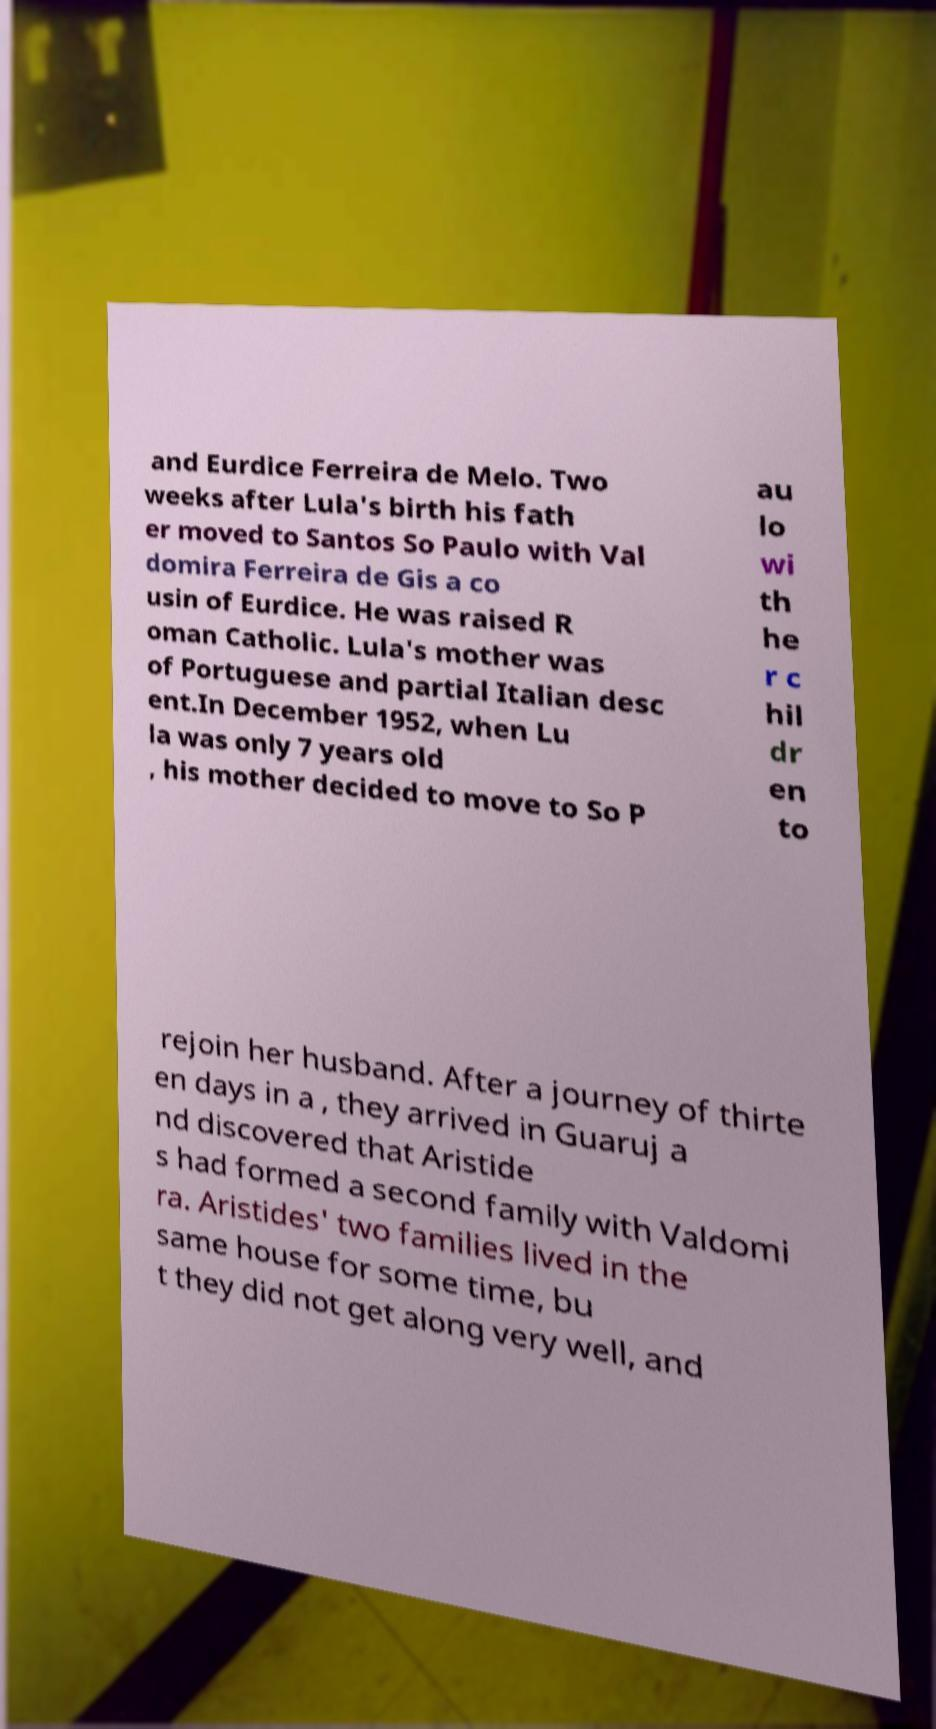I need the written content from this picture converted into text. Can you do that? and Eurdice Ferreira de Melo. Two weeks after Lula's birth his fath er moved to Santos So Paulo with Val domira Ferreira de Gis a co usin of Eurdice. He was raised R oman Catholic. Lula's mother was of Portuguese and partial Italian desc ent.In December 1952, when Lu la was only 7 years old , his mother decided to move to So P au lo wi th he r c hil dr en to rejoin her husband. After a journey of thirte en days in a , they arrived in Guaruj a nd discovered that Aristide s had formed a second family with Valdomi ra. Aristides' two families lived in the same house for some time, bu t they did not get along very well, and 